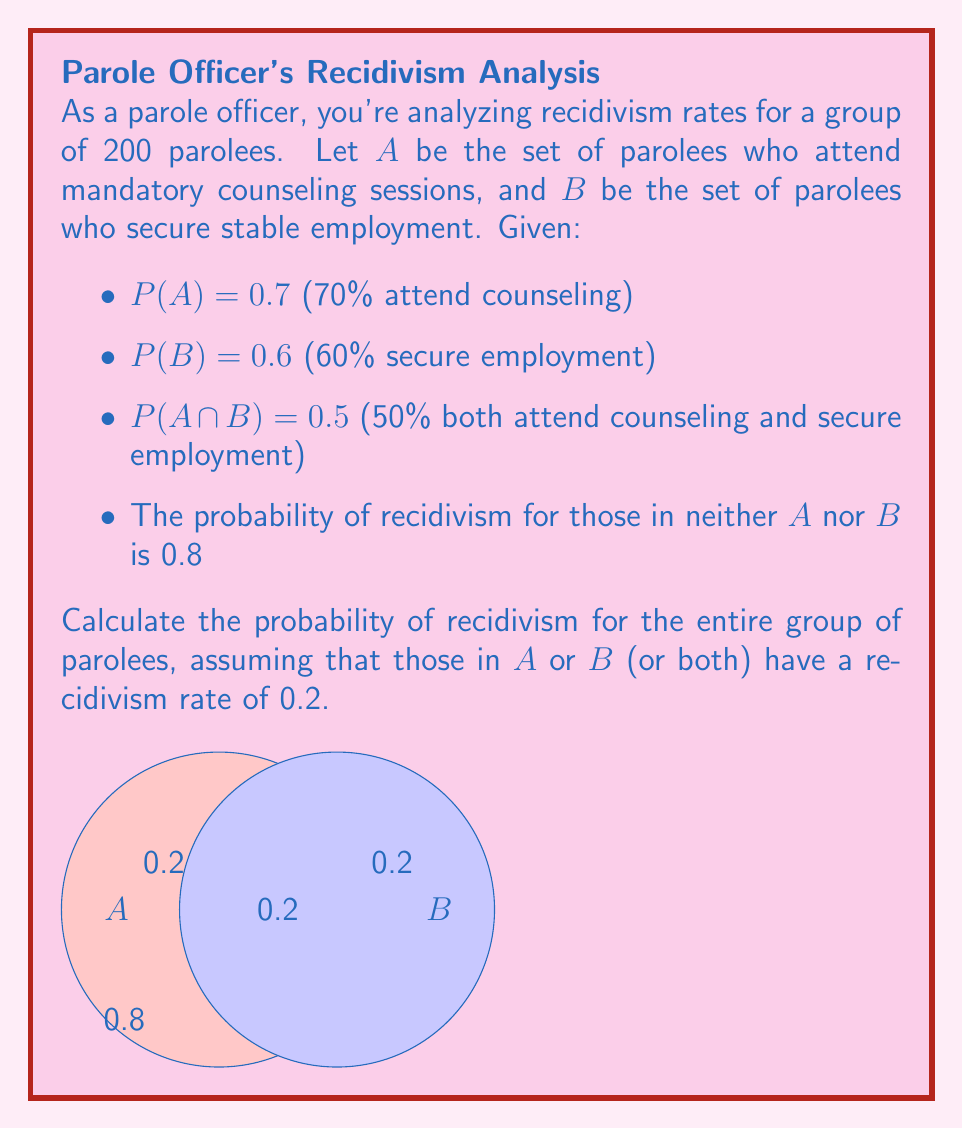Solve this math problem. Let's approach this step-by-step:

1) First, we need to find P(A ∪ B) using the given information:
   $$P(A ∪ B) = P(A) + P(B) - P(A ∩ B) = 0.7 + 0.6 - 0.5 = 0.8$$

2) This means that 80% of parolees are in either A or B or both, and 20% are in neither.

3) Let's define events:
   R: parolee recidivates
   C: parolee is in A or B or both (receives counseling or employment or both)

4) We can use the law of total probability:
   $$P(R) = P(R|C) * P(C) + P(R|C^c) * P(C^c)$$

   Where $C^c$ is the complement of C (neither A nor B)

5) We know:
   P(C) = P(A ∪ B) = 0.8
   P(C^c) = 1 - P(C) = 0.2
   P(R|C) = 0.2 (given in the question)
   P(R|C^c) = 0.8 (given in the question)

6) Substituting these values:
   $$P(R) = 0.2 * 0.8 + 0.8 * 0.2 = 0.16 + 0.16 = 0.32$$

Therefore, the probability of recidivism for the entire group is 0.32 or 32%.
Answer: 0.32 